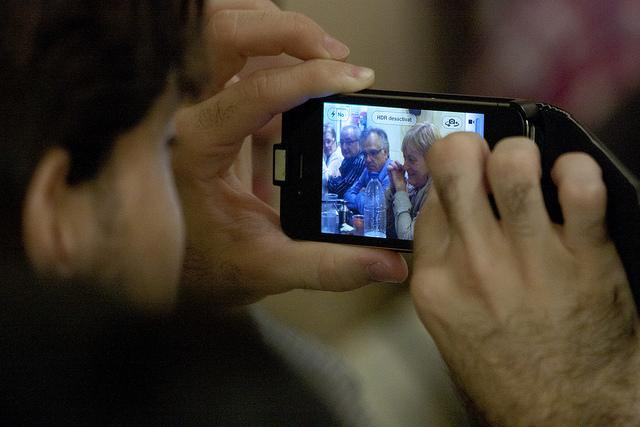Which is magnifying or moving towards yourself the photography is called?

Choices:
A) none
B) scroll
C) zoom
D) move zoom 